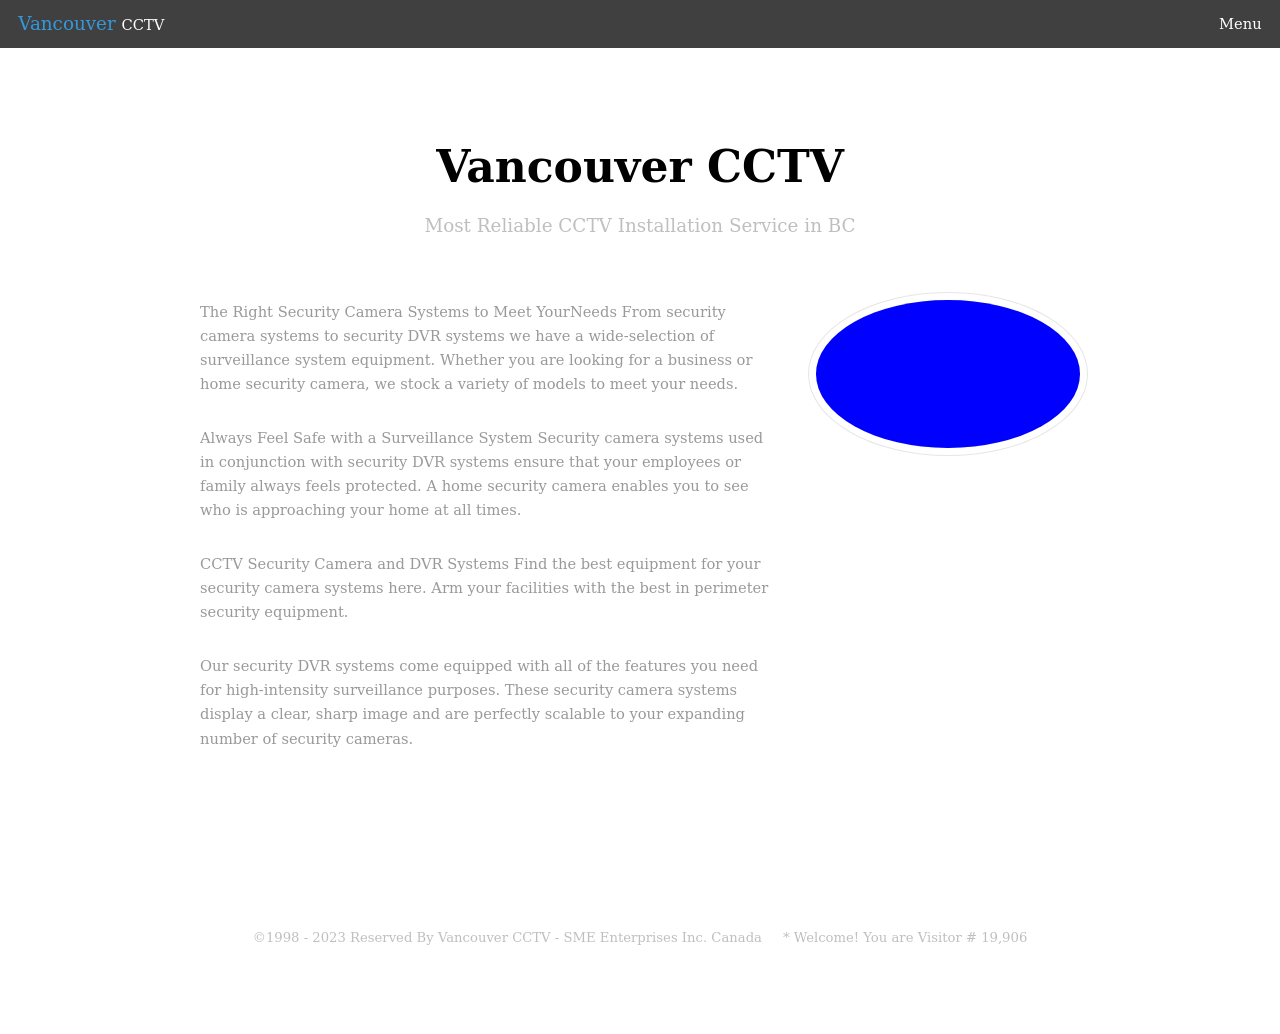Could you suggest improvements to enhance the accessibility of this website? Improving the accessibility of this website could involve several strategies. Firstly, adding alternative text descriptions (alt text) to all visual elements, including blue oval shapes, would help visually impaired users understand all content displayed. Secondly, ensuring that the website is fully navigable using keyboard shortcuts would aid individuals who cannot use a mouse. Another improvement could be the implementation of a contrasting color scheme for better visibility and readability, while maintaining the aesthetic integrity of the site. Lastly, introducing ARIA (Accessible Rich Internet Applications) roles and landmarks would significantly improve the website's navigational structure for screen readers. 